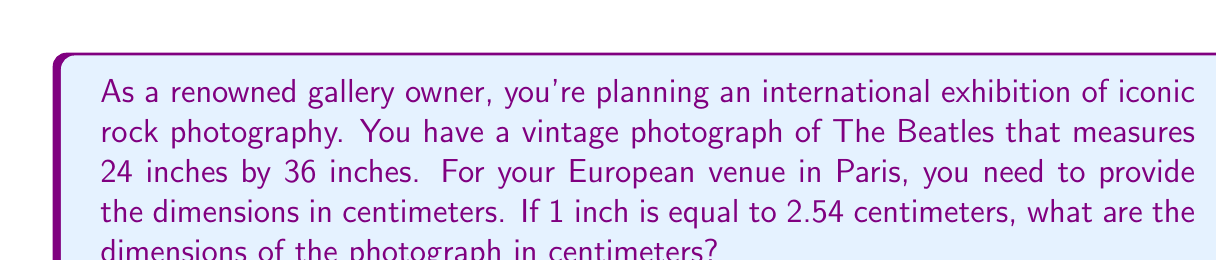Provide a solution to this math problem. To solve this problem, we need to convert the dimensions from inches to centimeters. We'll use the given conversion factor: 1 inch = 2.54 centimeters.

Let's convert each dimension separately:

1. For the width (24 inches):
   $24 \text{ inches} \times 2.54 \frac{\text{cm}}{\text{inch}} = 60.96 \text{ cm}$

2. For the length (36 inches):
   $36 \text{ inches} \times 2.54 \frac{\text{cm}}{\text{inch}} = 91.44 \text{ cm}$

The calculation can be represented as a general formula:
$$\text{Dimension in cm} = \text{Dimension in inches} \times 2.54$$

We round the results to the nearest centimeter for practical use in an exhibition setting.
Answer: The dimensions of the photograph for the Paris exhibition are approximately 61 cm by 91 cm. 